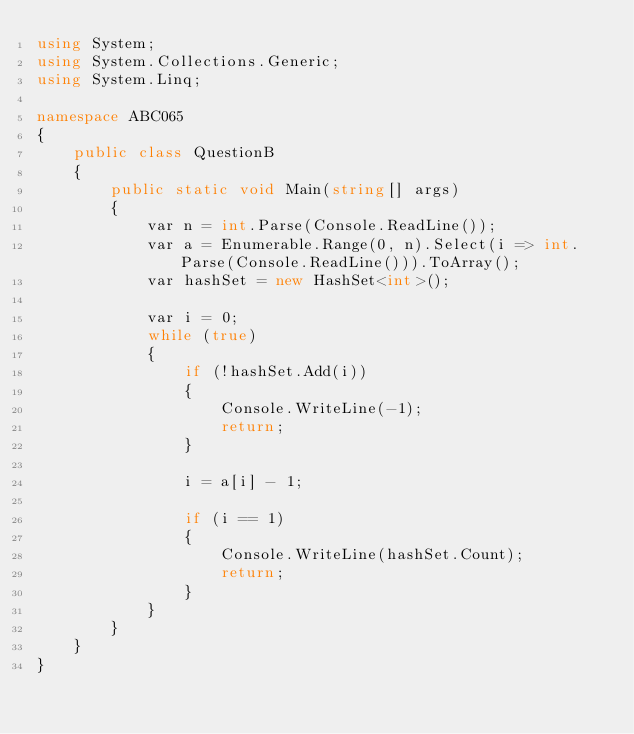<code> <loc_0><loc_0><loc_500><loc_500><_C#_>using System;
using System.Collections.Generic;
using System.Linq;

namespace ABC065
{
    public class QuestionB
    {
        public static void Main(string[] args)
        {
            var n = int.Parse(Console.ReadLine());
            var a = Enumerable.Range(0, n).Select(i => int.Parse(Console.ReadLine())).ToArray();
            var hashSet = new HashSet<int>();

            var i = 0;
            while (true)
            {
                if (!hashSet.Add(i))
                {
                    Console.WriteLine(-1);
                    return;
                }

                i = a[i] - 1;

                if (i == 1)
                {
                    Console.WriteLine(hashSet.Count);
                    return;
                }
            }
        }
    }
}
</code> 